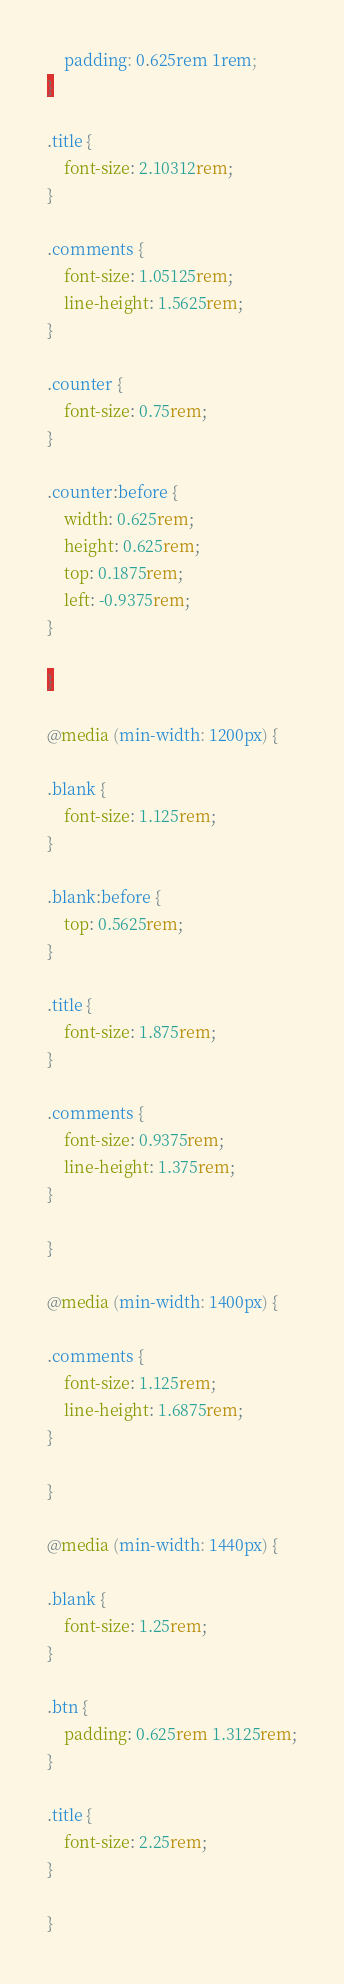<code> <loc_0><loc_0><loc_500><loc_500><_CSS_>	padding: 0.625rem 1rem;
}

.title {
	font-size: 2.10312rem;
}

.comments {
	font-size: 1.05125rem;
	line-height: 1.5625rem;
}

.counter {
	font-size: 0.75rem;
}

.counter:before {
	width: 0.625rem;
	height: 0.625rem;
	top: 0.1875rem;
	left: -0.9375rem;
}

}

@media (min-width: 1200px) {

.blank {
	font-size: 1.125rem;
}

.blank:before {
	top: 0.5625rem;
}

.title {
	font-size: 1.875rem;
}

.comments {
	font-size: 0.9375rem;
	line-height: 1.375rem;
}

}

@media (min-width: 1400px) {

.comments {
	font-size: 1.125rem;
	line-height: 1.6875rem;
}

}

@media (min-width: 1440px) {

.blank {
	font-size: 1.25rem;
}

.btn {
	padding: 0.625rem 1.3125rem;
}

.title {
	font-size: 2.25rem;
}

}

</code> 